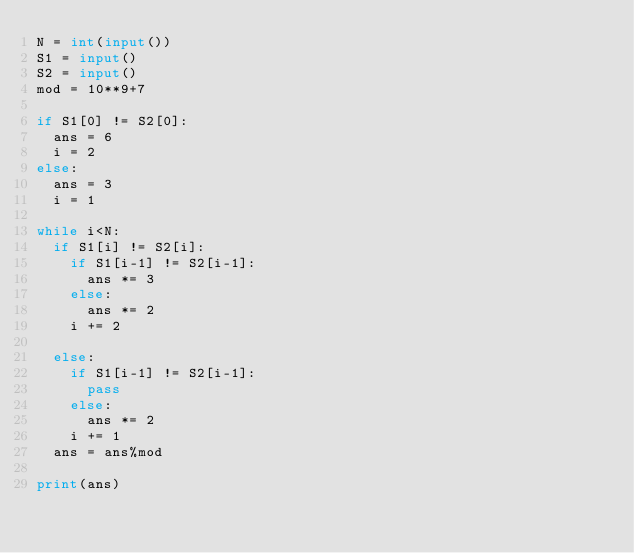<code> <loc_0><loc_0><loc_500><loc_500><_Python_>N = int(input())
S1 = input()
S2 = input()
mod = 10**9+7

if S1[0] != S2[0]:
  ans = 6
  i = 2
else:
  ans = 3
  i = 1
  
while i<N:
  if S1[i] != S2[i]:
    if S1[i-1] != S2[i-1]:
      ans *= 3
    else:
      ans *= 2
    i += 2
    
  else:
    if S1[i-1] != S2[i-1]:
      pass
    else:
      ans *= 2
    i += 1
  ans = ans%mod
  
print(ans)</code> 